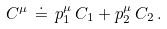Convert formula to latex. <formula><loc_0><loc_0><loc_500><loc_500>C ^ { \mu } \, \doteq \, p _ { 1 } ^ { \mu } \, C _ { 1 } + p _ { 2 } ^ { \mu } \, C _ { 2 } \, .</formula> 